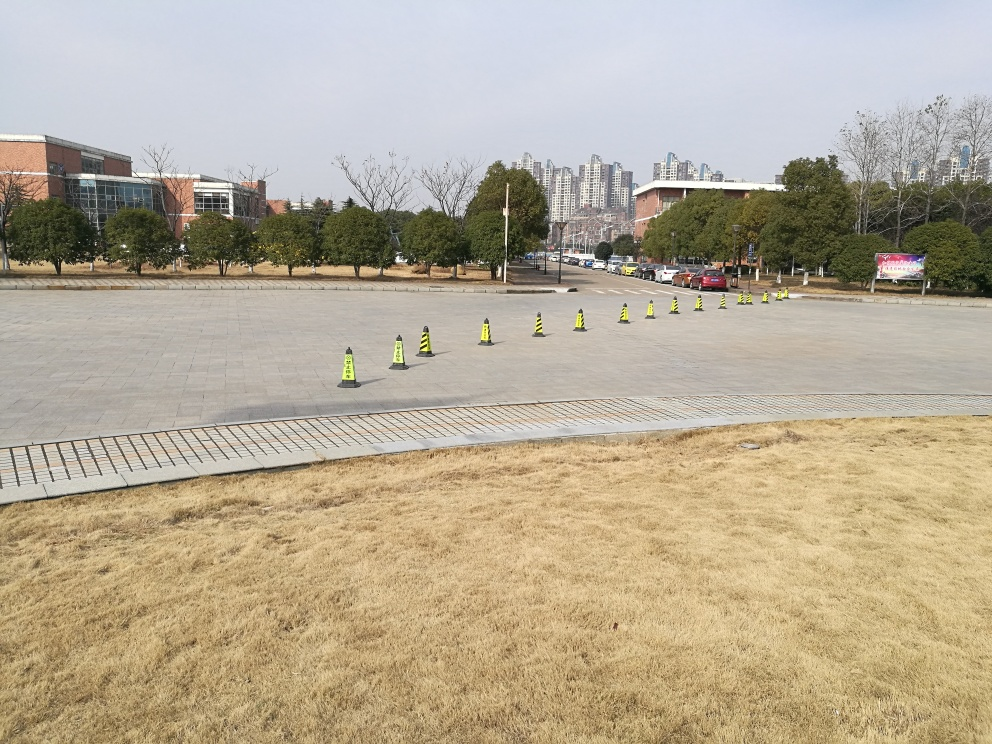How is the weather affecting the visibility of the scene? The weather appears to be clear and bright, with ample daylight that enhances the visibility of the scene. The absence of shadows cast by the cones suggests it might be an overcast day, which softens the light and diminishes harsh contrasts, still allowing for good visibility throughout the plaza. 